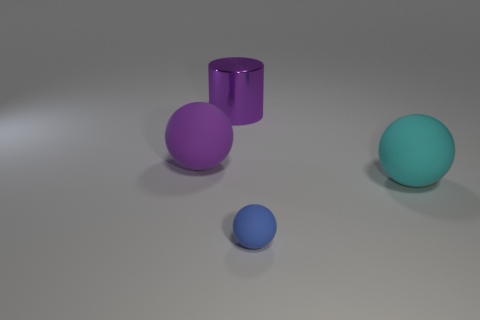There is a cyan thing; is it the same size as the purple metal thing that is on the left side of the tiny blue rubber sphere?
Your answer should be compact. Yes. There is a thing that is behind the big ball that is behind the ball to the right of the small rubber object; how big is it?
Offer a terse response. Large. What number of purple spheres are right of the purple ball?
Make the answer very short. 0. There is a purple thing behind the ball left of the tiny object; what is its material?
Provide a succinct answer. Metal. Are there any other things that are the same size as the blue rubber object?
Give a very brief answer. No. Is the shiny object the same size as the blue object?
Provide a succinct answer. No. How many things are matte spheres in front of the large purple rubber thing or large objects left of the small thing?
Provide a succinct answer. 4. Are there more purple balls that are behind the metallic thing than large brown shiny cylinders?
Give a very brief answer. No. What number of other objects are the same shape as the big metal thing?
Give a very brief answer. 0. There is a large object that is on the right side of the purple ball and to the left of the small ball; what material is it?
Your answer should be compact. Metal. 